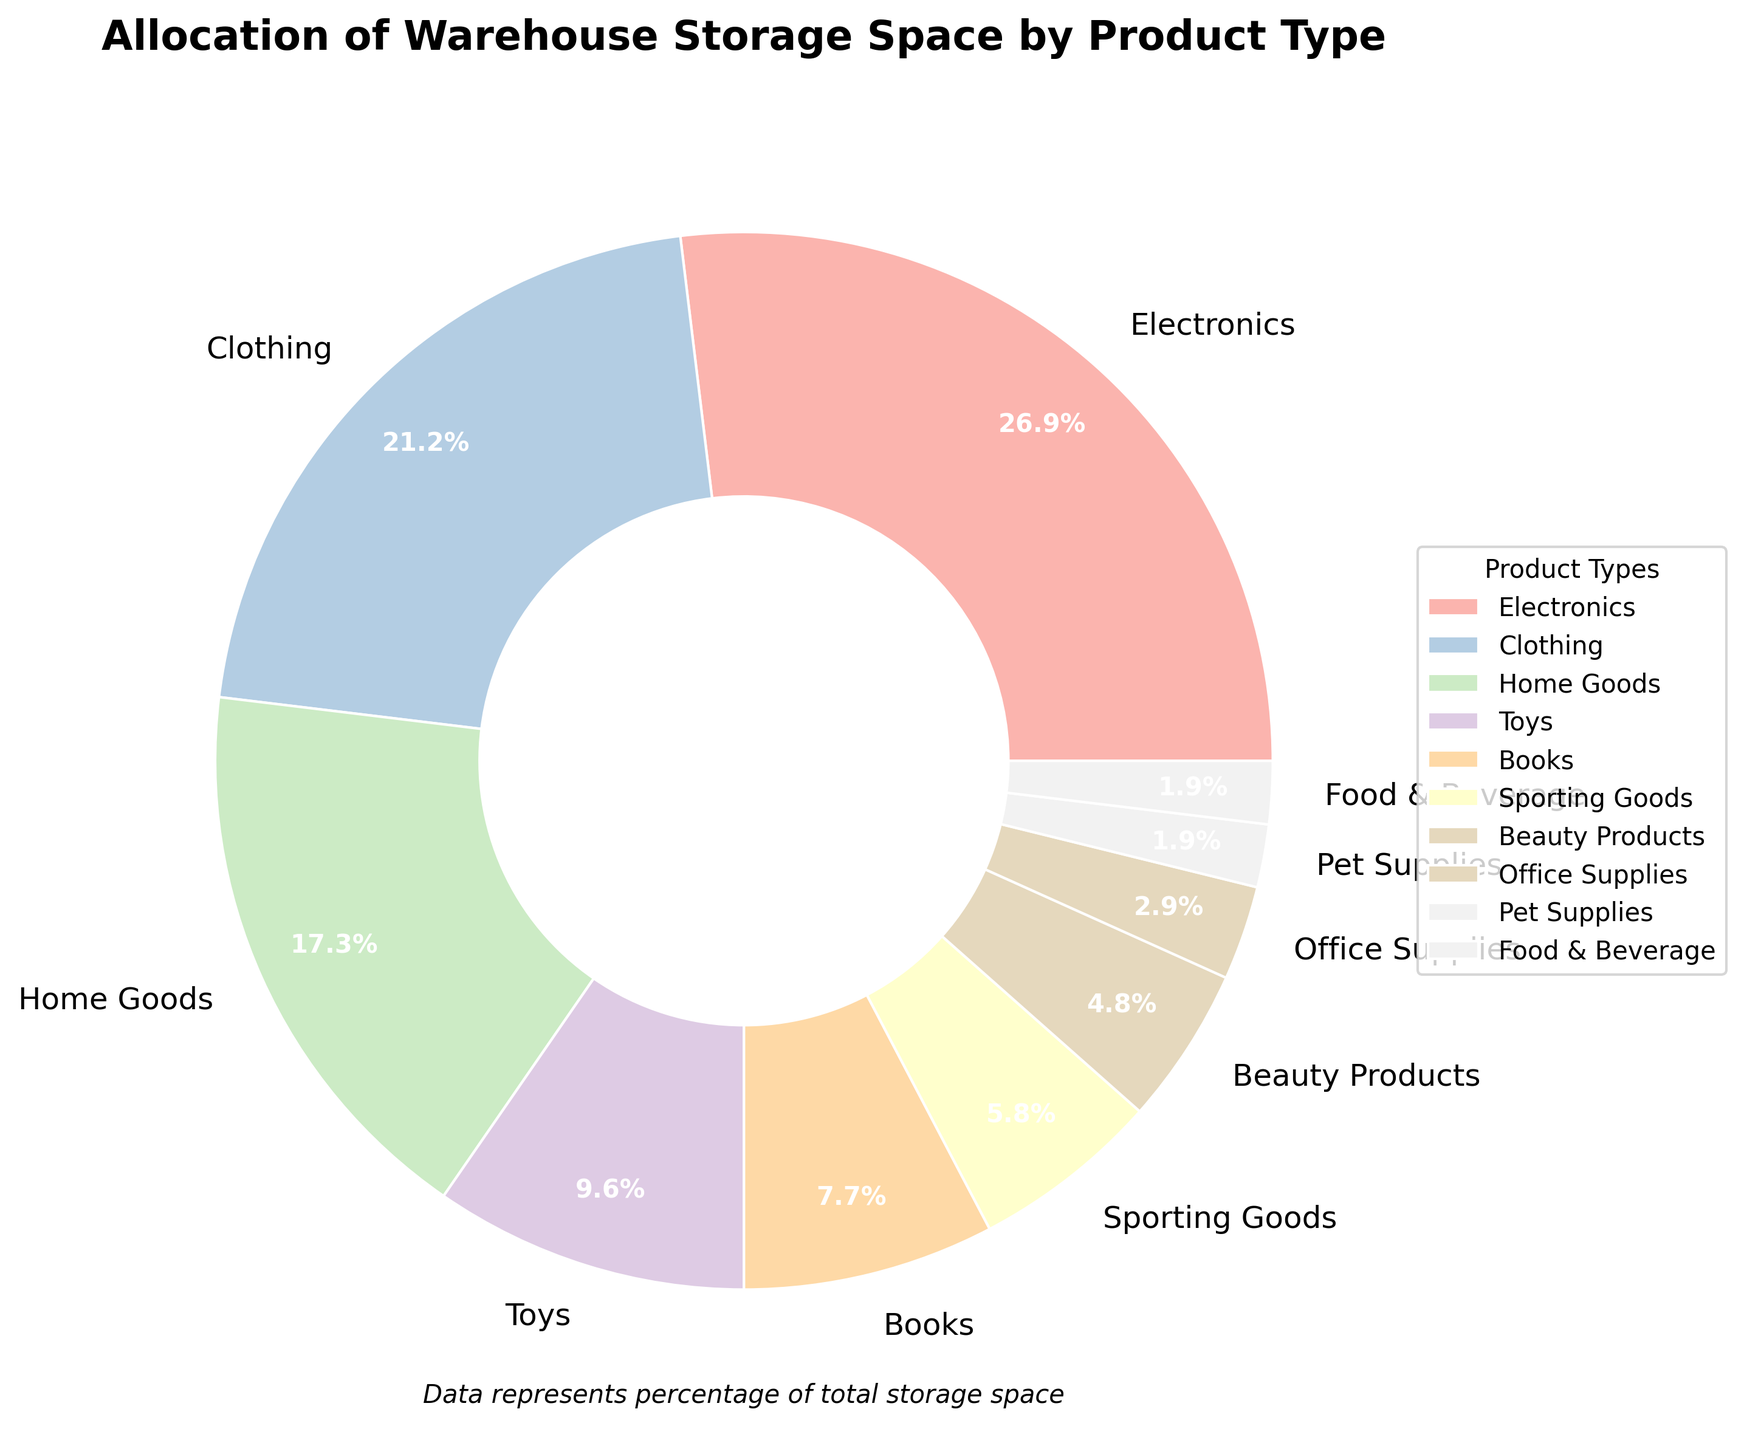What's the most allocated product type in the warehouse storage space? The pie chart shows that Electronics have the highest percentage of allocated storage space at 28%.
Answer: Electronics How much more storage space is allocated to Clothing than to Sporting Goods? Clothing has 22% of the storage space and Sporting Goods have 6%, so the difference is 22% - 6%.
Answer: 16% Which product type has the least amount of storage space? The pie chart shows that Pet Supplies and Food & Beverage have the smallest slices, each with 2%.
Answer: Pet Supplies and Food & Beverage How does the storage space of Home Goods compare to Books and Toys combined? Home Goods is allocated 18%, Books have 8% and Toys have 10%, the combined percentage of Books and Toys is 8% + 10% = 18%, which is equal to Home Goods.
Answer: Equal What percent of the warehouse storage is allocated to Beauty Products and Office Supplies together? Beauty Products have 5% and Office Supplies have 3%, so the total is 5% + 3%.
Answer: 8% If you combine the storage space for Home Goods, Toys, and Books, what is the total percentage? Home Goods is 18%, Toys are 10%, and Books are 8%, so the total is 18% + 10% + 8%.
Answer: 36% Which product types have a combined allocation of over 50% of the storage space? Combining the percentages: Electronics (28%), Clothing (22%), Home Goods (18%), Toys (10%), Books (8%), and Sporting Goods (6%) are the main contributors. Adding Electronics, Clothing, and Home Goods already exceeds 50%: 28% + 22% + 18% = 68%.
Answer: Electronics, Clothing, and Home Goods What is the difference between the storage spaces allocated to Electronics and Food & Beverage? Electronics have 28%, and Food & Beverage have 2%, so the difference is 28% - 2%.
Answer: 26% Is the combined storage percentage for Toys and Sporting Goods greater than that for Home Goods? Toys have 10% and Sporting Goods have 6%, making a combined percentage of 10% + 6% = 16%. Home Goods have 18%, so 16% is less than 18%.
Answer: No How much more storage space is allocated to Beauty Products compared to Pet Supplies? Beauty Products have 5% and Pet Supplies have 2%, so the difference is 5% - 2%.
Answer: 3% 